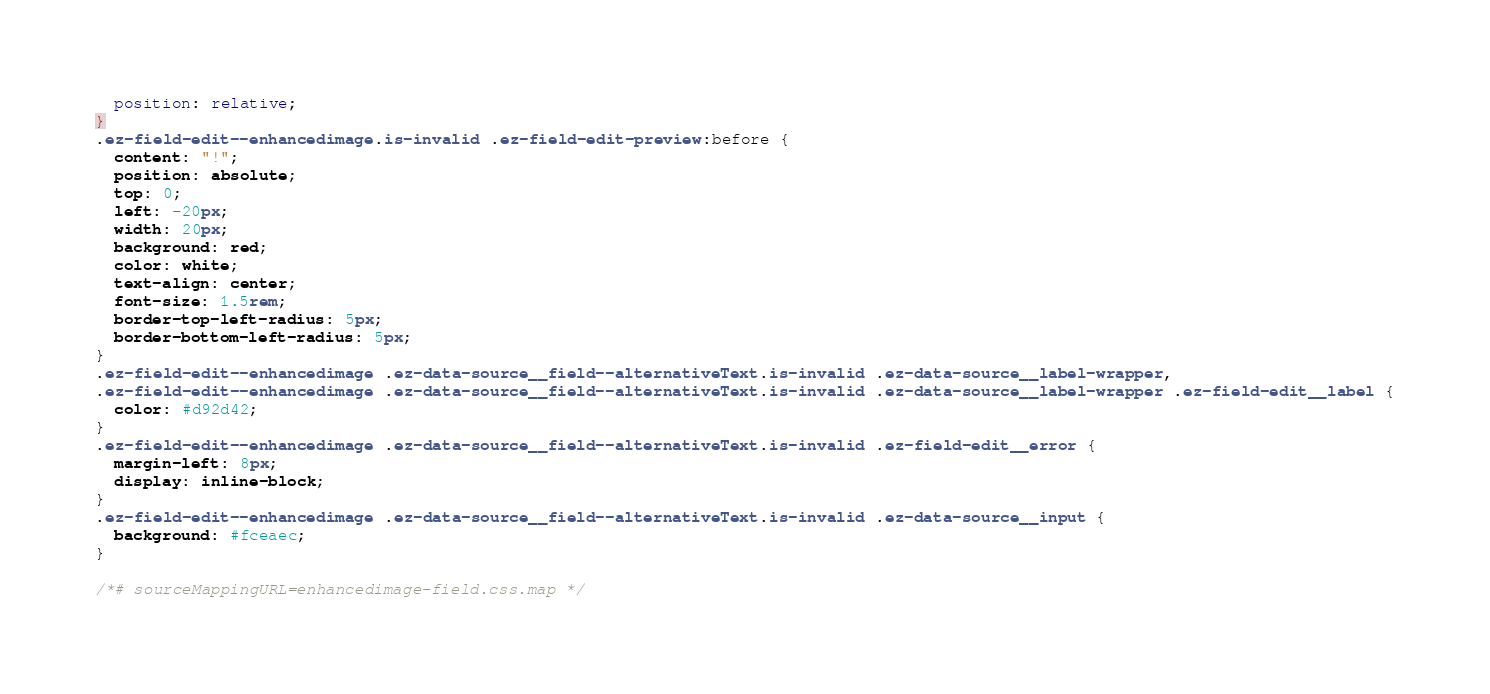Convert code to text. <code><loc_0><loc_0><loc_500><loc_500><_CSS_>  position: relative;
}
.ez-field-edit--enhancedimage.is-invalid .ez-field-edit-preview:before {
  content: "!";
  position: absolute;
  top: 0;
  left: -20px;
  width: 20px;
  background: red;
  color: white;
  text-align: center;
  font-size: 1.5rem;
  border-top-left-radius: 5px;
  border-bottom-left-radius: 5px;
}
.ez-field-edit--enhancedimage .ez-data-source__field--alternativeText.is-invalid .ez-data-source__label-wrapper,
.ez-field-edit--enhancedimage .ez-data-source__field--alternativeText.is-invalid .ez-data-source__label-wrapper .ez-field-edit__label {
  color: #d92d42;
}
.ez-field-edit--enhancedimage .ez-data-source__field--alternativeText.is-invalid .ez-field-edit__error {
  margin-left: 8px;
  display: inline-block;
}
.ez-field-edit--enhancedimage .ez-data-source__field--alternativeText.is-invalid .ez-data-source__input {
  background: #fceaec;
}

/*# sourceMappingURL=enhancedimage-field.css.map */
</code> 